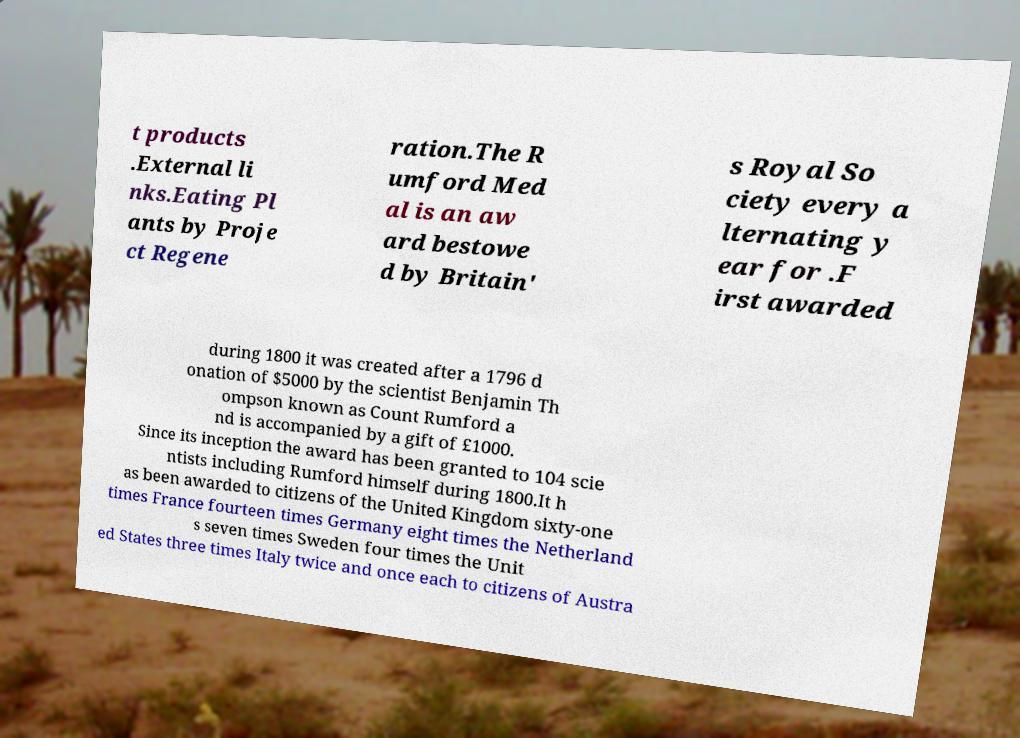What messages or text are displayed in this image? I need them in a readable, typed format. t products .External li nks.Eating Pl ants by Proje ct Regene ration.The R umford Med al is an aw ard bestowe d by Britain' s Royal So ciety every a lternating y ear for .F irst awarded during 1800 it was created after a 1796 d onation of $5000 by the scientist Benjamin Th ompson known as Count Rumford a nd is accompanied by a gift of £1000. Since its inception the award has been granted to 104 scie ntists including Rumford himself during 1800.It h as been awarded to citizens of the United Kingdom sixty-one times France fourteen times Germany eight times the Netherland s seven times Sweden four times the Unit ed States three times Italy twice and once each to citizens of Austra 